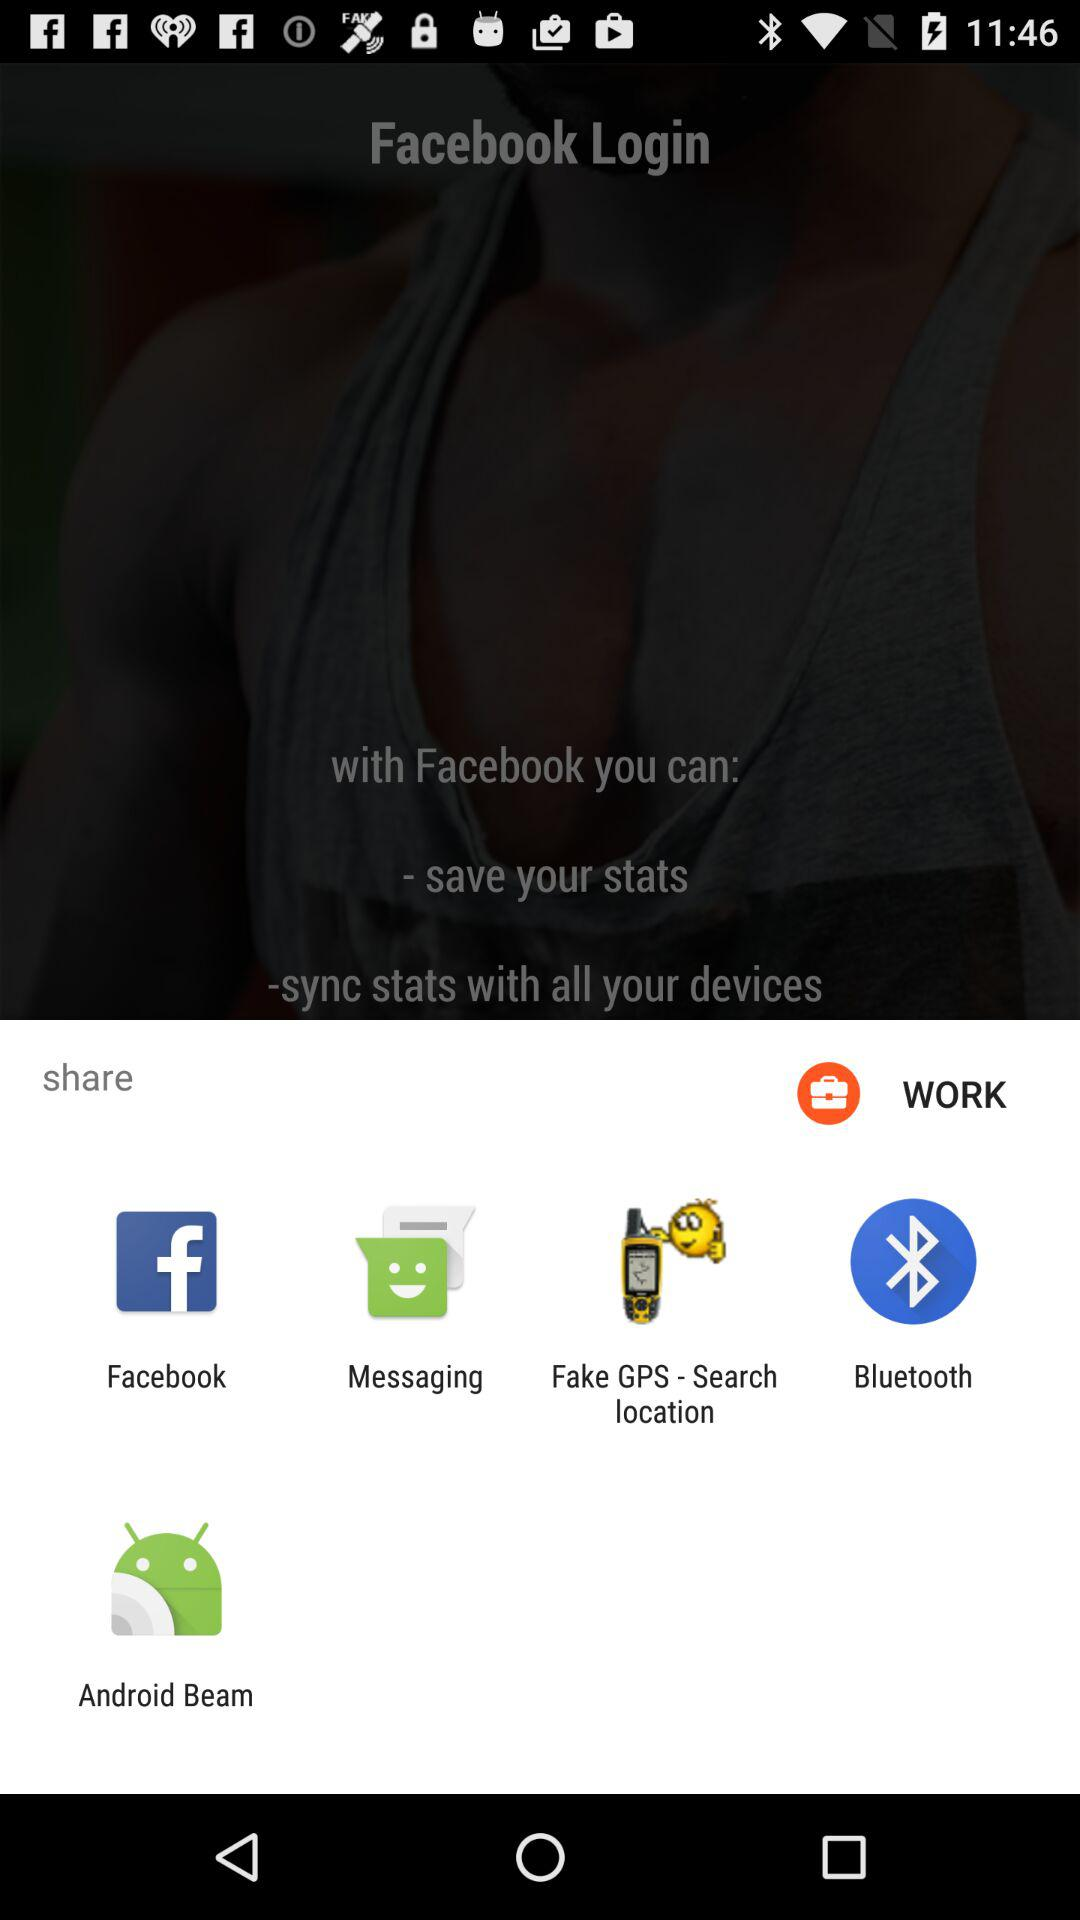Through what applications can content be shared? Content can be shared with "Facebook", "Messaging", "Fake GPS - Search location", "Bluetooth" and "Android Beam". 